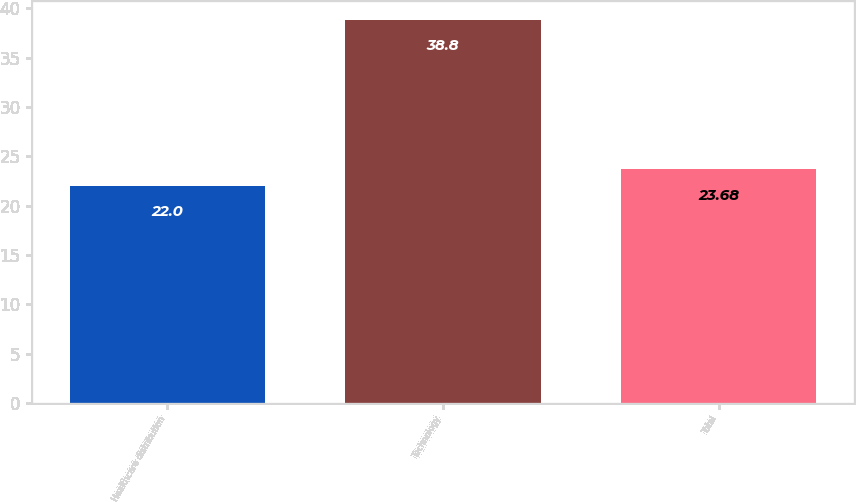Convert chart. <chart><loc_0><loc_0><loc_500><loc_500><bar_chart><fcel>Healthcare distribution<fcel>Technology<fcel>Total<nl><fcel>22<fcel>38.8<fcel>23.68<nl></chart> 